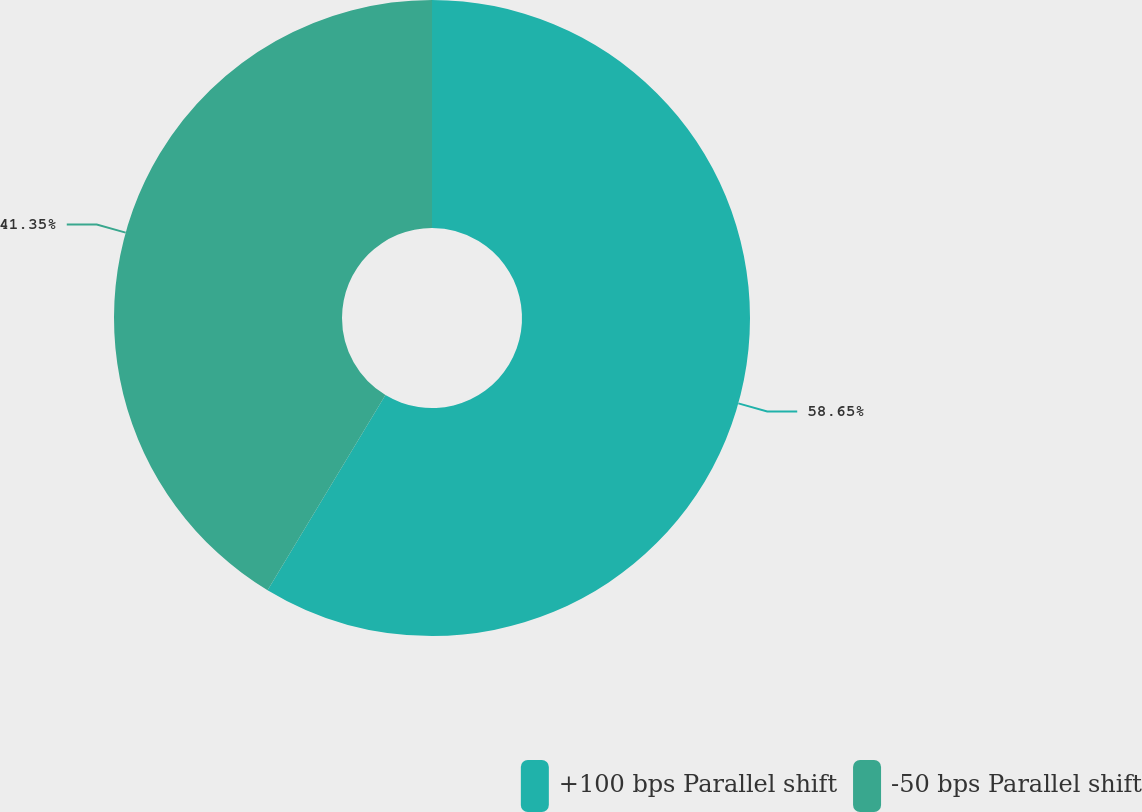Convert chart. <chart><loc_0><loc_0><loc_500><loc_500><pie_chart><fcel>+100 bps Parallel shift<fcel>-50 bps Parallel shift<nl><fcel>58.65%<fcel>41.35%<nl></chart> 